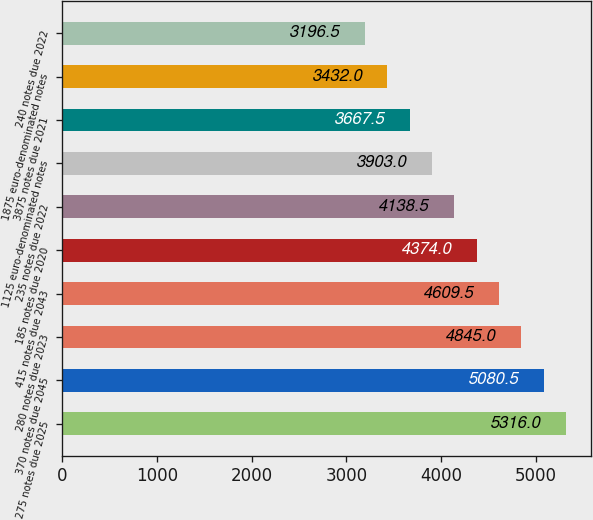Convert chart. <chart><loc_0><loc_0><loc_500><loc_500><bar_chart><fcel>275 notes due 2025<fcel>370 notes due 2045<fcel>280 notes due 2023<fcel>415 notes due 2043<fcel>185 notes due 2020<fcel>235 notes due 2022<fcel>1125 euro-denominated notes<fcel>3875 notes due 2021<fcel>1875 euro-denominated notes<fcel>240 notes due 2022<nl><fcel>5316<fcel>5080.5<fcel>4845<fcel>4609.5<fcel>4374<fcel>4138.5<fcel>3903<fcel>3667.5<fcel>3432<fcel>3196.5<nl></chart> 